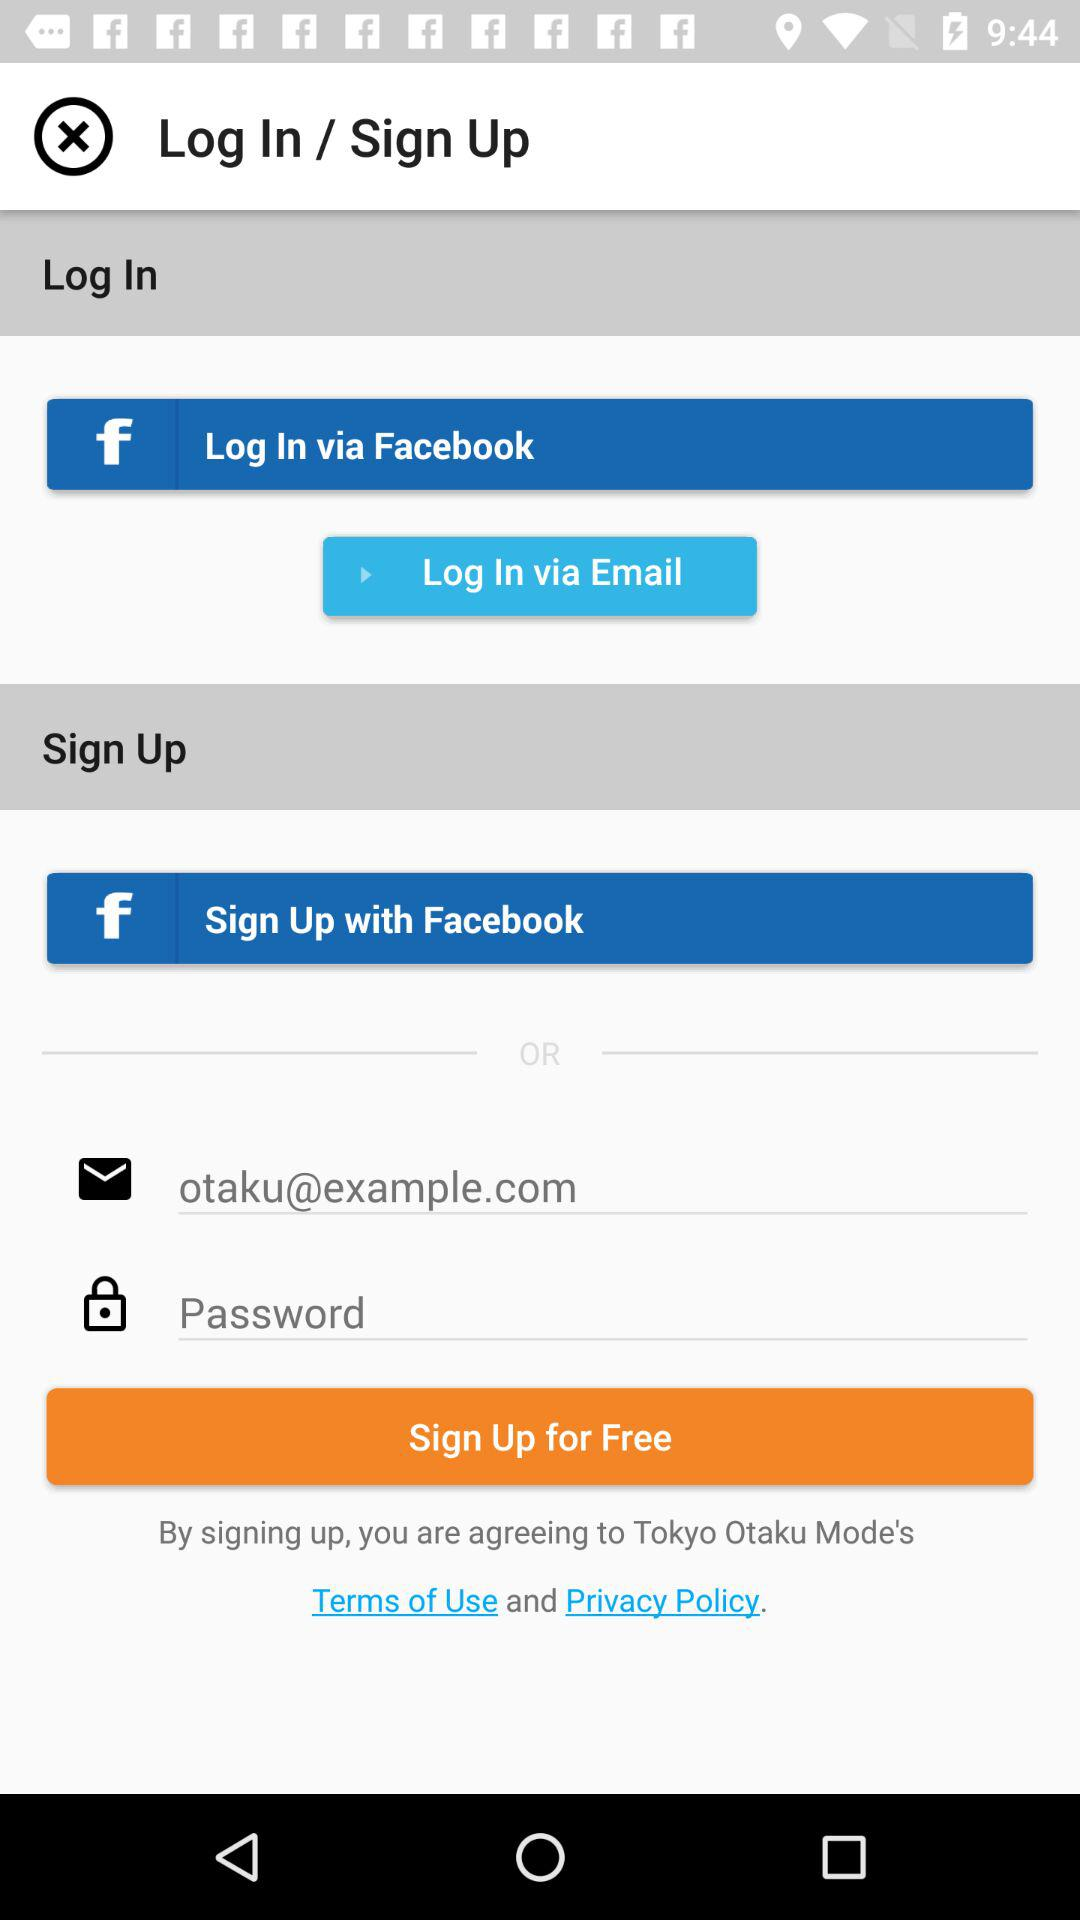How can we log in? You can log in with "Facebook" and "Email". 